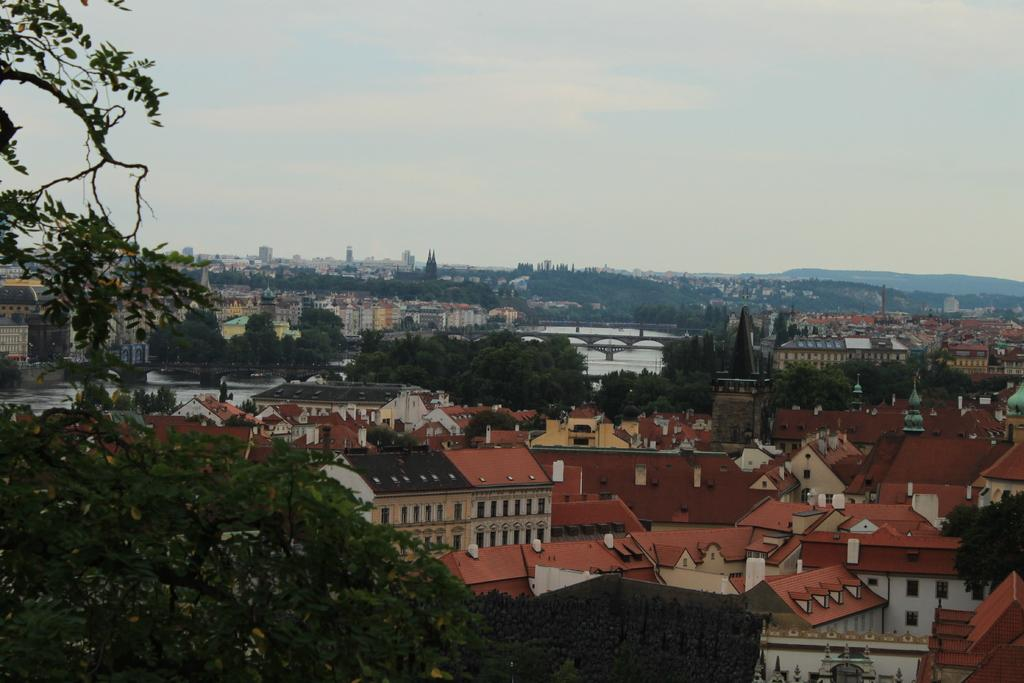What type of structures can be seen in the image? There are buildings in the image. What type of vegetation is present in the image? There are trees in the image. What type of natural landform can be seen in the image? There are hills in the image. image. What is visible in the background of the image? The sky is visible in the image. Where is the net located in the image? There is no net present in the image. What type of army can be seen in the image? There is no army present in the image. 